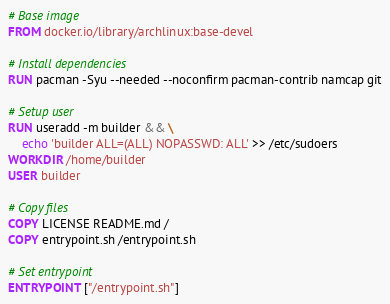<code> <loc_0><loc_0><loc_500><loc_500><_Dockerfile_># Base image
FROM docker.io/library/archlinux:base-devel

# Install dependencies
RUN pacman -Syu --needed --noconfirm pacman-contrib namcap git

# Setup user
RUN useradd -m builder && \
    echo 'builder ALL=(ALL) NOPASSWD: ALL' >> /etc/sudoers
WORKDIR /home/builder
USER builder

# Copy files
COPY LICENSE README.md /
COPY entrypoint.sh /entrypoint.sh

# Set entrypoint
ENTRYPOINT ["/entrypoint.sh"]
</code> 